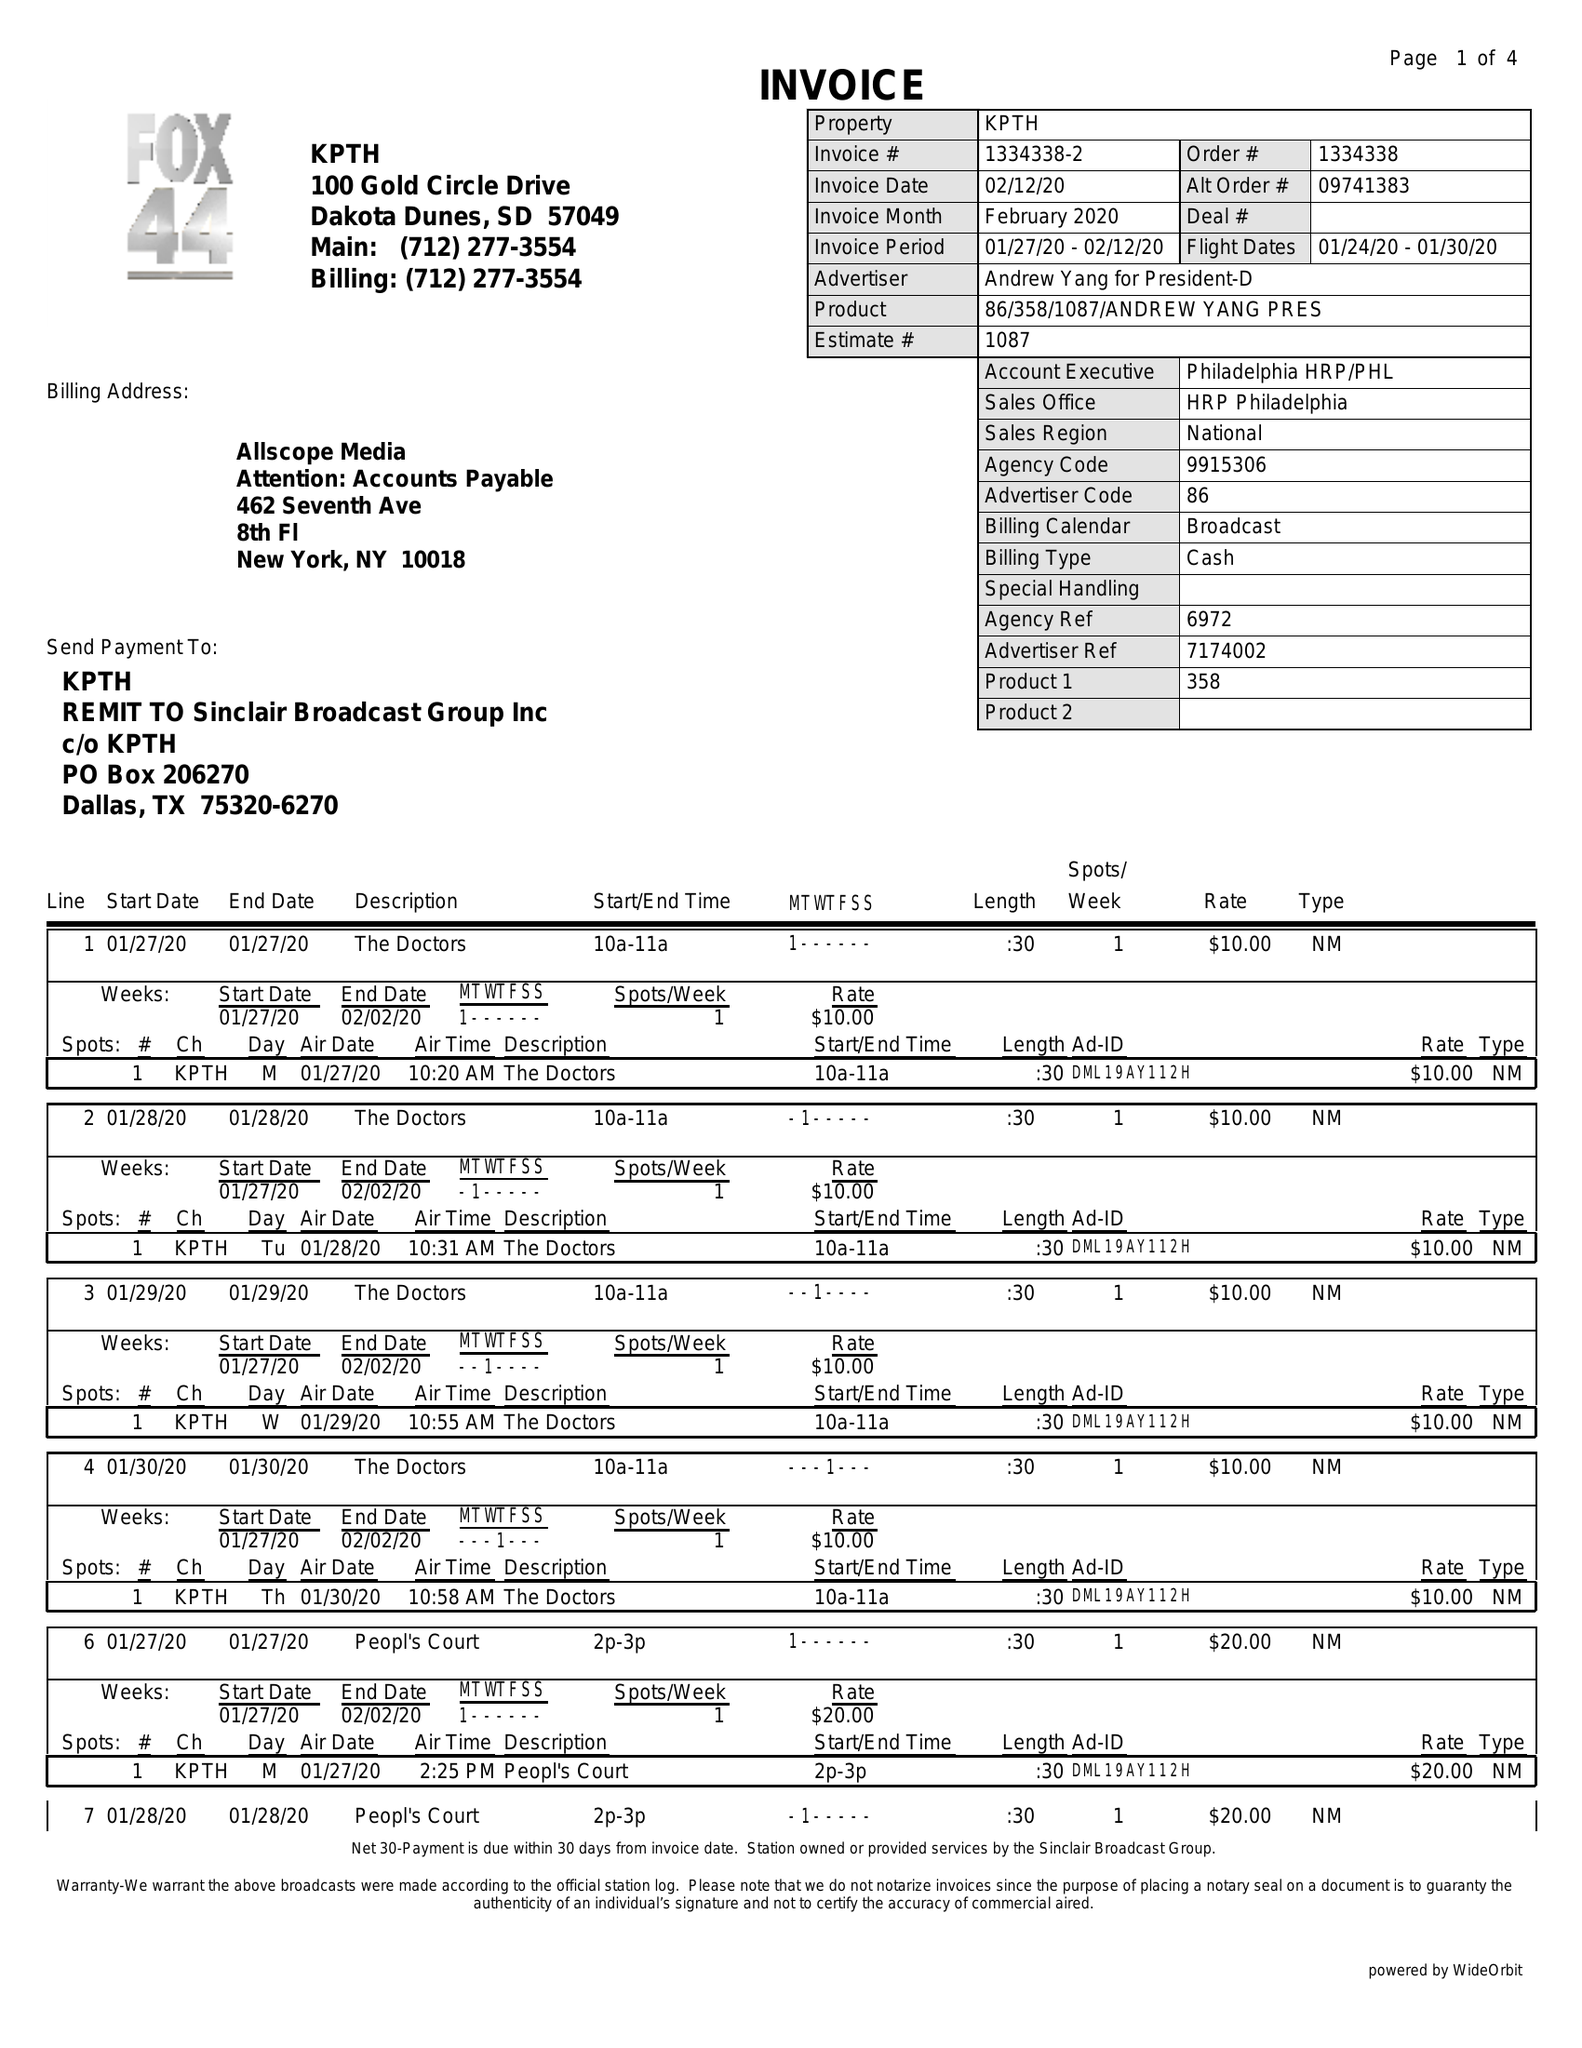What is the value for the flight_to?
Answer the question using a single word or phrase. 01/30/20 